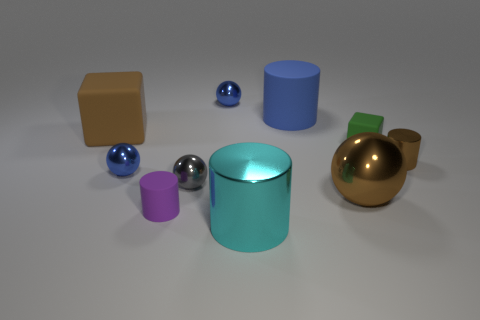Subtract all blue cubes. Subtract all red cylinders. How many cubes are left? 2 Subtract all blocks. How many objects are left? 8 Subtract 1 gray balls. How many objects are left? 9 Subtract all purple rubber things. Subtract all big balls. How many objects are left? 8 Add 1 tiny purple objects. How many tiny purple objects are left? 2 Add 2 large cyan shiny objects. How many large cyan shiny objects exist? 3 